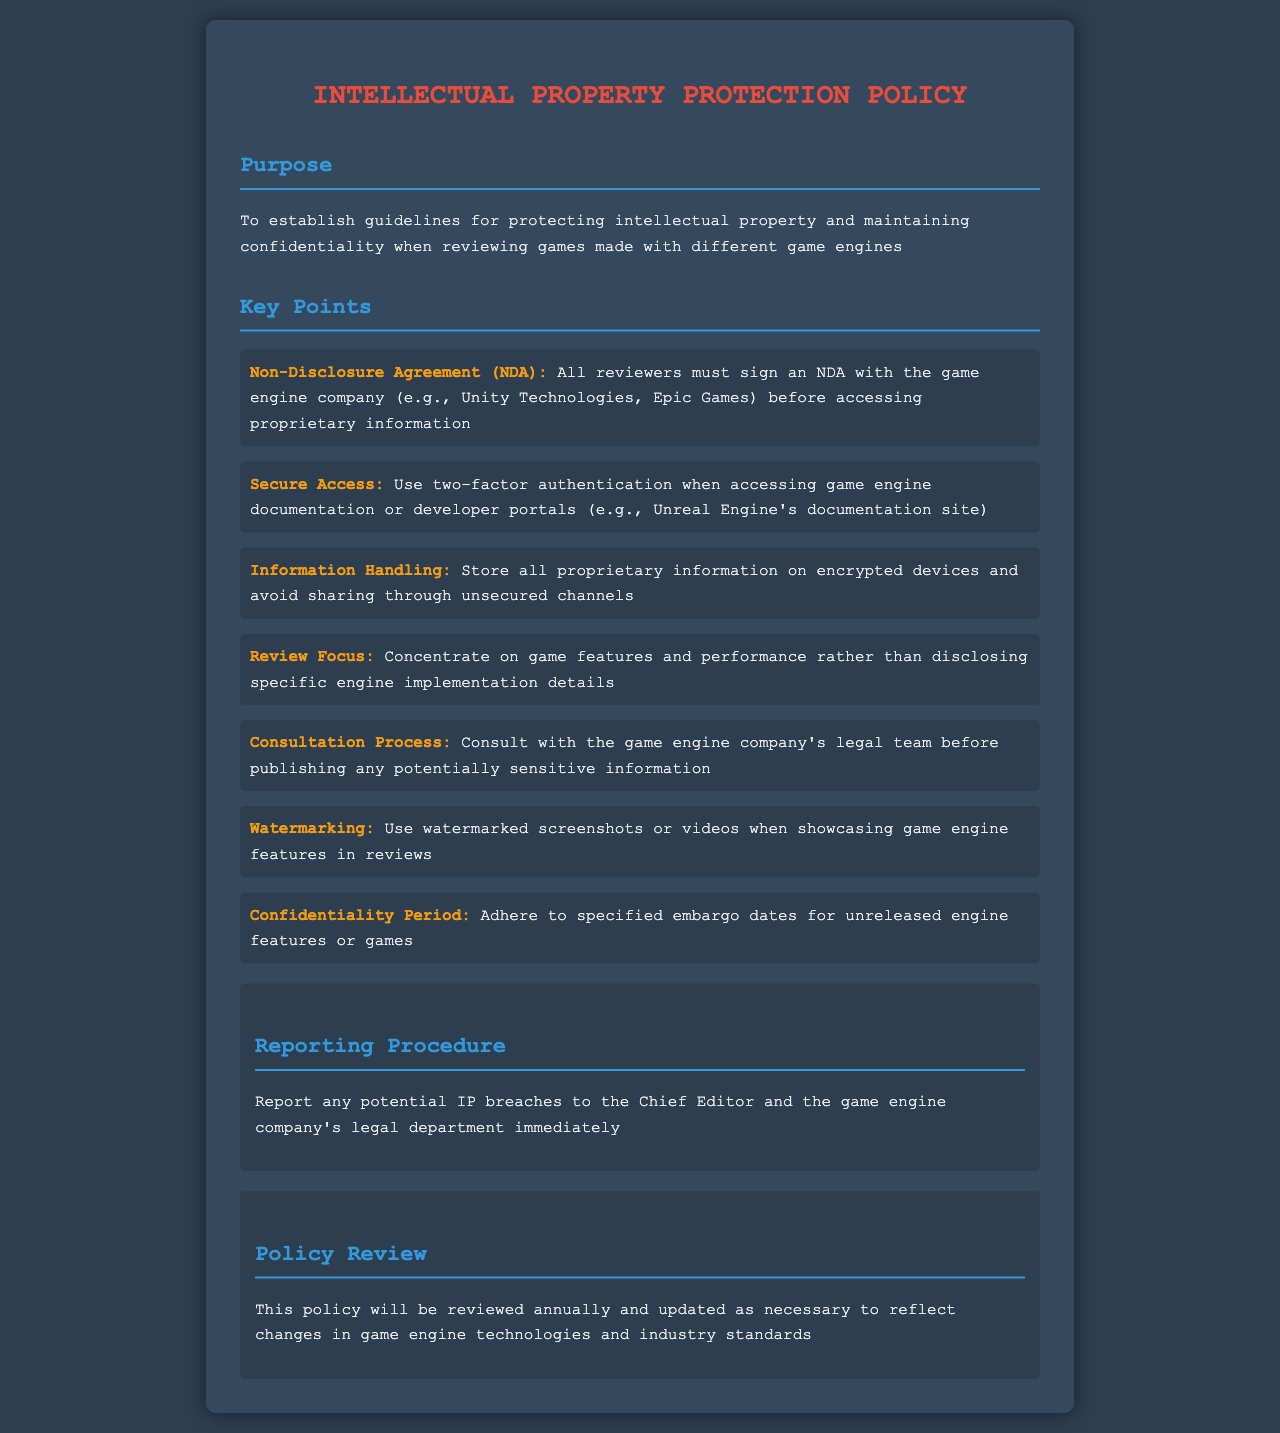What is the purpose of the policy? The purpose of the policy is to establish guidelines for protecting intellectual property and maintaining confidentiality when reviewing games made with different game engines.
Answer: Protecting intellectual property and maintaining confidentiality What must reviewers sign before accessing proprietary information? Reviewers must sign a Non-Disclosure Agreement (NDA) with the game engine company.
Answer: Non-Disclosure Agreement (NDA) What should be used for secure access to game engine documentation? Two-factor authentication should be used when accessing game engine documentation.
Answer: Two-factor authentication What type of information handling is advised regarding proprietary information? Store all proprietary information on encrypted devices and avoid sharing through unsecured channels.
Answer: Encrypted devices Who should be consulted before publishing sensitive information? The game engine company's legal team should be consulted before publishing sensitive information.
Answer: Game engine company's legal team What is required when showcasing game engine features? Watermarked screenshots or videos should be used when showcasing game engine features.
Answer: Watermarked screenshots or videos What is the confidentiality period related to? The confidentiality period relates to adhering to specified embargo dates for unreleased engine features or games.
Answer: Embargo dates How often will the policy be reviewed? The policy will be reviewed annually to reflect changes in game engine technologies and industry standards.
Answer: Annually To whom should potential IP breaches be reported? Potential IP breaches should be reported to the Chief Editor and the game engine company's legal department.
Answer: Chief Editor and legal department 